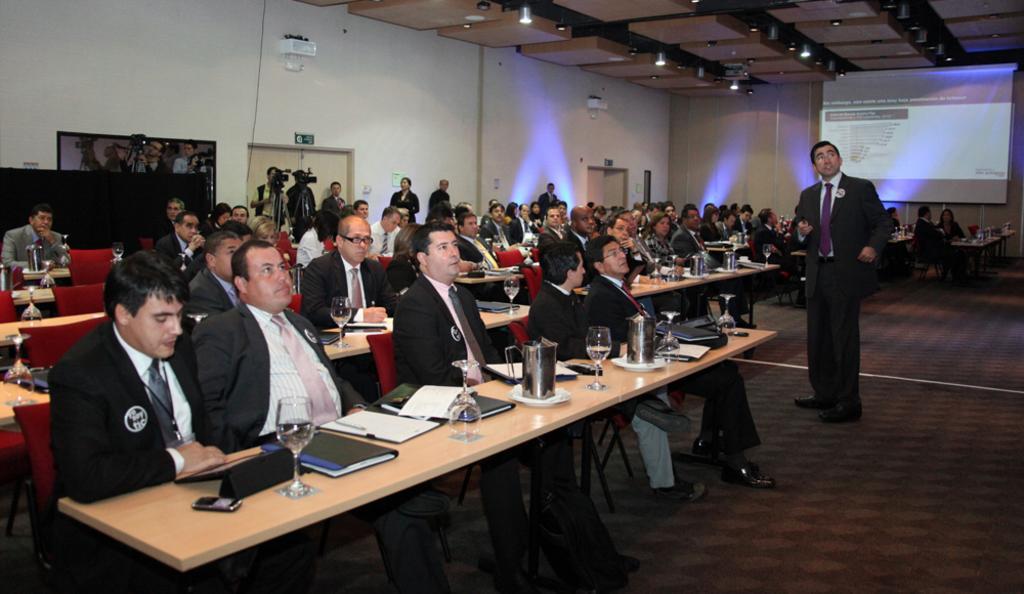How would you summarize this image in a sentence or two? In a room there are many people sitting. And there is a man with black jacket and violet tie is standing. In front of them there are some tables. On the table there is a glass, file , mobile, papers and name board. In the background there are some cameraman. There is a door and to the right top there is a screen. 